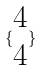Convert formula to latex. <formula><loc_0><loc_0><loc_500><loc_500>\{ \begin{matrix} 4 \\ 4 \end{matrix} \}</formula> 